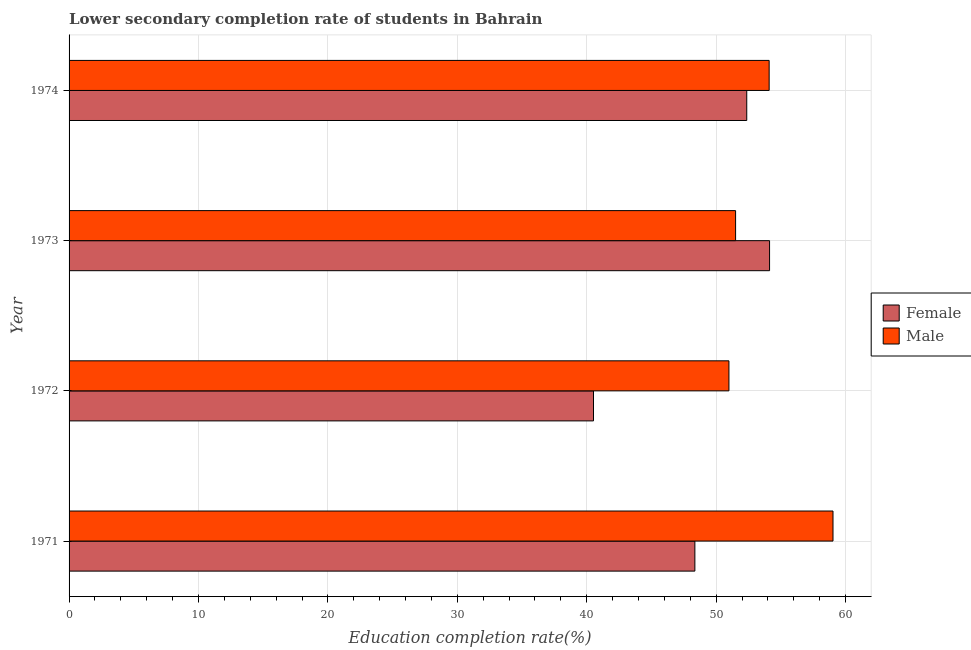How many different coloured bars are there?
Your answer should be very brief. 2. Are the number of bars per tick equal to the number of legend labels?
Your answer should be very brief. Yes. Are the number of bars on each tick of the Y-axis equal?
Your answer should be compact. Yes. How many bars are there on the 3rd tick from the top?
Give a very brief answer. 2. What is the education completion rate of female students in 1973?
Offer a very short reply. 54.13. Across all years, what is the maximum education completion rate of female students?
Offer a very short reply. 54.13. Across all years, what is the minimum education completion rate of female students?
Ensure brevity in your answer.  40.52. What is the total education completion rate of male students in the graph?
Your answer should be compact. 215.62. What is the difference between the education completion rate of female students in 1973 and that in 1974?
Provide a short and direct response. 1.76. What is the difference between the education completion rate of male students in 1973 and the education completion rate of female students in 1974?
Provide a short and direct response. -0.86. What is the average education completion rate of female students per year?
Your answer should be compact. 48.84. In the year 1971, what is the difference between the education completion rate of male students and education completion rate of female students?
Keep it short and to the point. 10.67. In how many years, is the education completion rate of female students greater than 12 %?
Give a very brief answer. 4. What is the ratio of the education completion rate of female students in 1971 to that in 1972?
Your answer should be very brief. 1.19. Is the difference between the education completion rate of male students in 1971 and 1973 greater than the difference between the education completion rate of female students in 1971 and 1973?
Keep it short and to the point. Yes. What is the difference between the highest and the second highest education completion rate of male students?
Keep it short and to the point. 4.93. What is the difference between the highest and the lowest education completion rate of female students?
Offer a terse response. 13.6. Is the sum of the education completion rate of male students in 1973 and 1974 greater than the maximum education completion rate of female students across all years?
Ensure brevity in your answer.  Yes. What does the 2nd bar from the top in 1974 represents?
Offer a terse response. Female. What does the 1st bar from the bottom in 1973 represents?
Offer a terse response. Female. Are all the bars in the graph horizontal?
Provide a short and direct response. Yes. Where does the legend appear in the graph?
Ensure brevity in your answer.  Center right. How many legend labels are there?
Provide a short and direct response. 2. How are the legend labels stacked?
Your response must be concise. Vertical. What is the title of the graph?
Your response must be concise. Lower secondary completion rate of students in Bahrain. What is the label or title of the X-axis?
Keep it short and to the point. Education completion rate(%). What is the Education completion rate(%) in Female in 1971?
Make the answer very short. 48.36. What is the Education completion rate(%) in Male in 1971?
Your answer should be compact. 59.03. What is the Education completion rate(%) of Female in 1972?
Keep it short and to the point. 40.52. What is the Education completion rate(%) in Male in 1972?
Your answer should be very brief. 50.99. What is the Education completion rate(%) in Female in 1973?
Offer a terse response. 54.13. What is the Education completion rate(%) in Male in 1973?
Provide a short and direct response. 51.5. What is the Education completion rate(%) in Female in 1974?
Provide a succinct answer. 52.36. What is the Education completion rate(%) in Male in 1974?
Offer a very short reply. 54.1. Across all years, what is the maximum Education completion rate(%) in Female?
Give a very brief answer. 54.13. Across all years, what is the maximum Education completion rate(%) of Male?
Give a very brief answer. 59.03. Across all years, what is the minimum Education completion rate(%) in Female?
Your answer should be compact. 40.52. Across all years, what is the minimum Education completion rate(%) of Male?
Your answer should be very brief. 50.99. What is the total Education completion rate(%) of Female in the graph?
Give a very brief answer. 195.37. What is the total Education completion rate(%) in Male in the graph?
Provide a short and direct response. 215.62. What is the difference between the Education completion rate(%) in Female in 1971 and that in 1972?
Your answer should be compact. 7.83. What is the difference between the Education completion rate(%) of Male in 1971 and that in 1972?
Keep it short and to the point. 8.04. What is the difference between the Education completion rate(%) of Female in 1971 and that in 1973?
Your answer should be very brief. -5.77. What is the difference between the Education completion rate(%) in Male in 1971 and that in 1973?
Offer a terse response. 7.53. What is the difference between the Education completion rate(%) of Female in 1971 and that in 1974?
Keep it short and to the point. -4.01. What is the difference between the Education completion rate(%) in Male in 1971 and that in 1974?
Make the answer very short. 4.93. What is the difference between the Education completion rate(%) of Female in 1972 and that in 1973?
Offer a terse response. -13.6. What is the difference between the Education completion rate(%) in Male in 1972 and that in 1973?
Ensure brevity in your answer.  -0.51. What is the difference between the Education completion rate(%) in Female in 1972 and that in 1974?
Keep it short and to the point. -11.84. What is the difference between the Education completion rate(%) of Male in 1972 and that in 1974?
Offer a terse response. -3.11. What is the difference between the Education completion rate(%) of Female in 1973 and that in 1974?
Ensure brevity in your answer.  1.76. What is the difference between the Education completion rate(%) of Male in 1973 and that in 1974?
Ensure brevity in your answer.  -2.59. What is the difference between the Education completion rate(%) of Female in 1971 and the Education completion rate(%) of Male in 1972?
Offer a very short reply. -2.63. What is the difference between the Education completion rate(%) in Female in 1971 and the Education completion rate(%) in Male in 1973?
Offer a very short reply. -3.15. What is the difference between the Education completion rate(%) in Female in 1971 and the Education completion rate(%) in Male in 1974?
Offer a very short reply. -5.74. What is the difference between the Education completion rate(%) in Female in 1972 and the Education completion rate(%) in Male in 1973?
Your response must be concise. -10.98. What is the difference between the Education completion rate(%) of Female in 1972 and the Education completion rate(%) of Male in 1974?
Offer a very short reply. -13.57. What is the difference between the Education completion rate(%) of Female in 1973 and the Education completion rate(%) of Male in 1974?
Offer a very short reply. 0.03. What is the average Education completion rate(%) of Female per year?
Keep it short and to the point. 48.84. What is the average Education completion rate(%) of Male per year?
Give a very brief answer. 53.9. In the year 1971, what is the difference between the Education completion rate(%) in Female and Education completion rate(%) in Male?
Make the answer very short. -10.67. In the year 1972, what is the difference between the Education completion rate(%) in Female and Education completion rate(%) in Male?
Offer a very short reply. -10.47. In the year 1973, what is the difference between the Education completion rate(%) in Female and Education completion rate(%) in Male?
Ensure brevity in your answer.  2.63. In the year 1974, what is the difference between the Education completion rate(%) in Female and Education completion rate(%) in Male?
Keep it short and to the point. -1.73. What is the ratio of the Education completion rate(%) of Female in 1971 to that in 1972?
Provide a short and direct response. 1.19. What is the ratio of the Education completion rate(%) of Male in 1971 to that in 1972?
Keep it short and to the point. 1.16. What is the ratio of the Education completion rate(%) of Female in 1971 to that in 1973?
Keep it short and to the point. 0.89. What is the ratio of the Education completion rate(%) in Male in 1971 to that in 1973?
Your response must be concise. 1.15. What is the ratio of the Education completion rate(%) in Female in 1971 to that in 1974?
Your answer should be compact. 0.92. What is the ratio of the Education completion rate(%) of Male in 1971 to that in 1974?
Your answer should be compact. 1.09. What is the ratio of the Education completion rate(%) of Female in 1972 to that in 1973?
Make the answer very short. 0.75. What is the ratio of the Education completion rate(%) in Male in 1972 to that in 1973?
Make the answer very short. 0.99. What is the ratio of the Education completion rate(%) of Female in 1972 to that in 1974?
Ensure brevity in your answer.  0.77. What is the ratio of the Education completion rate(%) in Male in 1972 to that in 1974?
Make the answer very short. 0.94. What is the ratio of the Education completion rate(%) of Female in 1973 to that in 1974?
Ensure brevity in your answer.  1.03. What is the difference between the highest and the second highest Education completion rate(%) in Female?
Your response must be concise. 1.76. What is the difference between the highest and the second highest Education completion rate(%) of Male?
Provide a succinct answer. 4.93. What is the difference between the highest and the lowest Education completion rate(%) of Female?
Your answer should be very brief. 13.6. What is the difference between the highest and the lowest Education completion rate(%) in Male?
Your answer should be very brief. 8.04. 